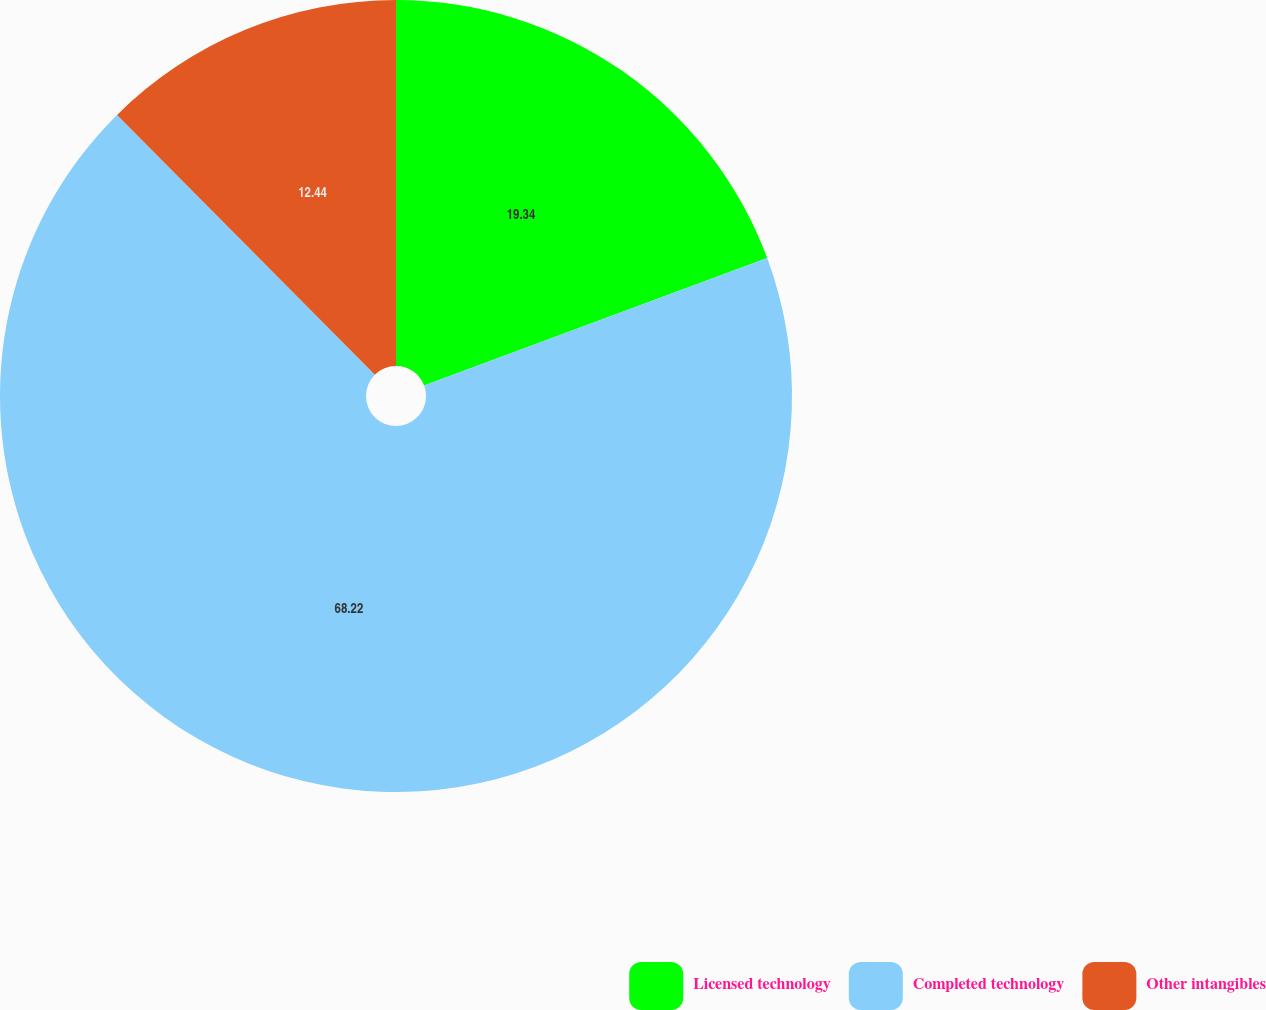Convert chart to OTSL. <chart><loc_0><loc_0><loc_500><loc_500><pie_chart><fcel>Licensed technology<fcel>Completed technology<fcel>Other intangibles<nl><fcel>19.34%<fcel>68.22%<fcel>12.44%<nl></chart> 